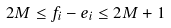<formula> <loc_0><loc_0><loc_500><loc_500>2 M \leq f _ { i } - e _ { i } \leq 2 M + 1</formula> 